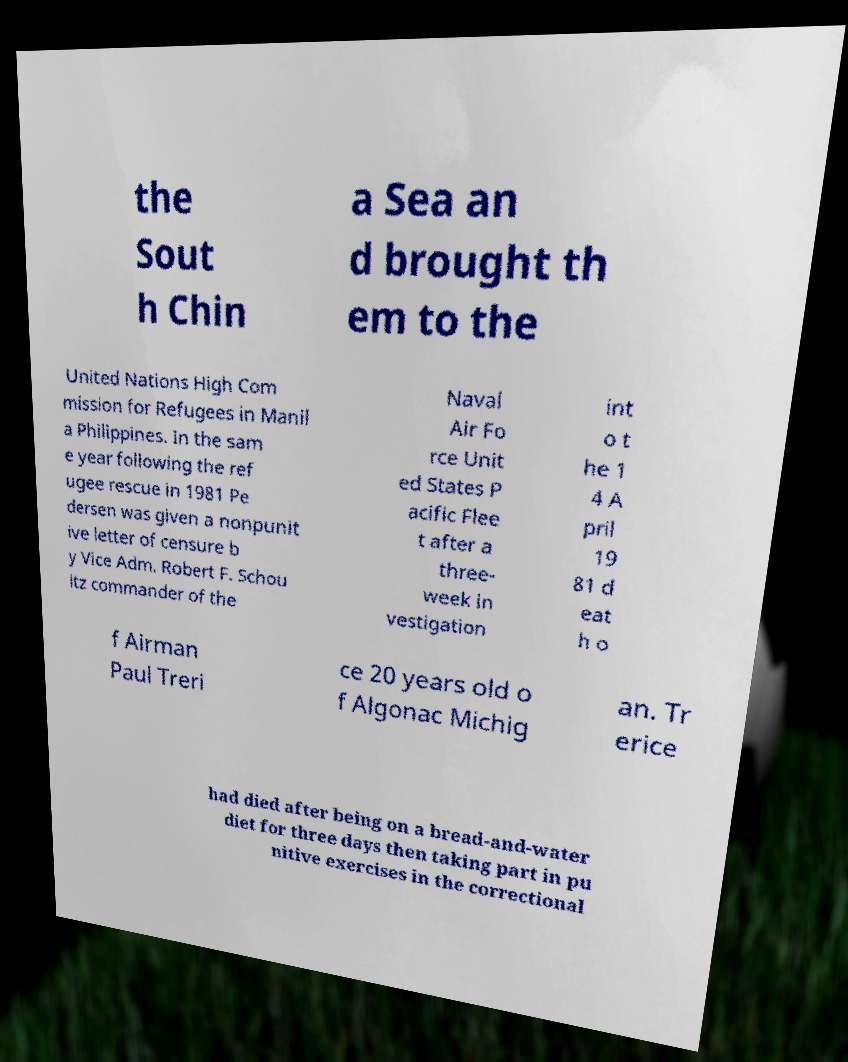I need the written content from this picture converted into text. Can you do that? the Sout h Chin a Sea an d brought th em to the United Nations High Com mission for Refugees in Manil a Philippines. In the sam e year following the ref ugee rescue in 1981 Pe dersen was given a nonpunit ive letter of censure b y Vice Adm. Robert F. Schou ltz commander of the Naval Air Fo rce Unit ed States P acific Flee t after a three- week in vestigation int o t he 1 4 A pril 19 81 d eat h o f Airman Paul Treri ce 20 years old o f Algonac Michig an. Tr erice had died after being on a bread-and-water diet for three days then taking part in pu nitive exercises in the correctional 